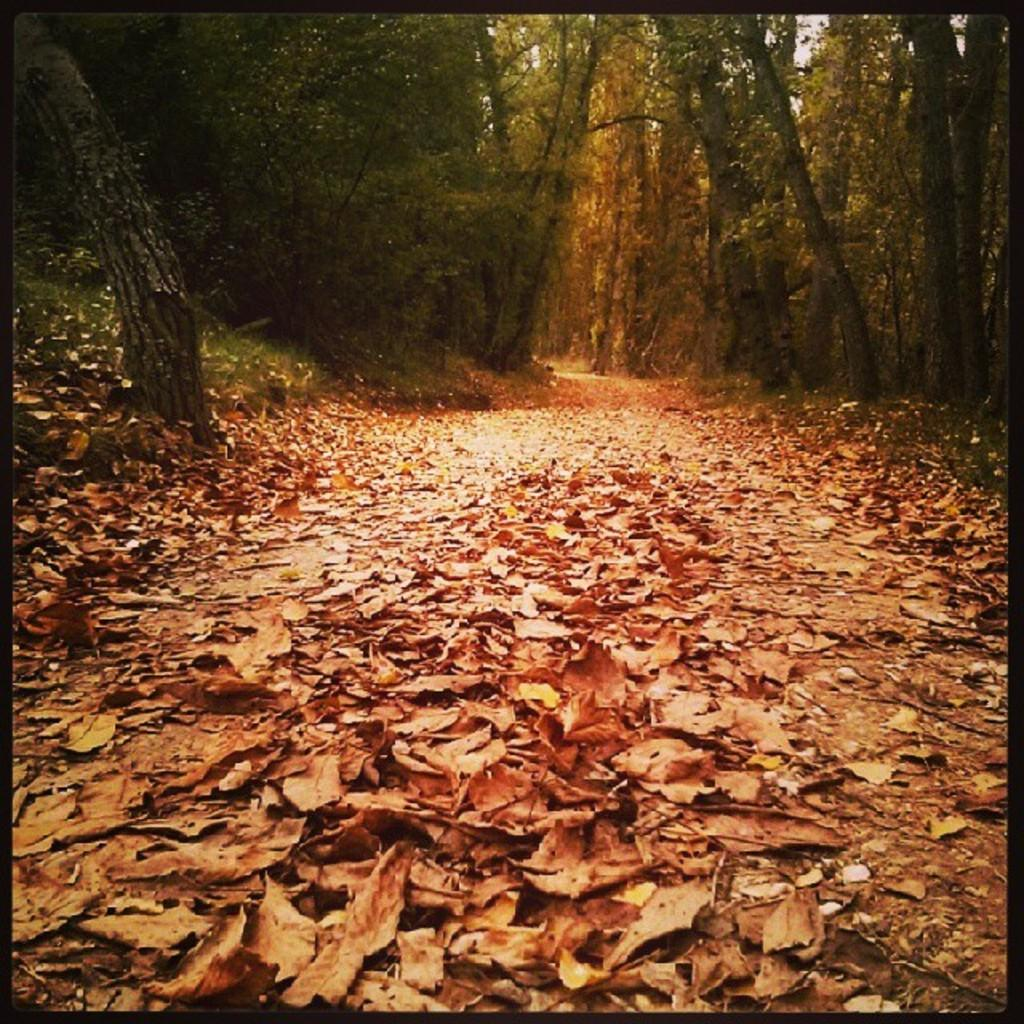What type of vegetation can be seen in the image? There are trees and grass in the image. What is covering the ground in the image? There are dried leaves on the land in the image. Is there any indication of a path or walkway in the image? Yes, there is a path between the trees in the image. What is the skin condition of the trees in the image? There is no mention of a skin condition in the image, as trees do not have skin. 